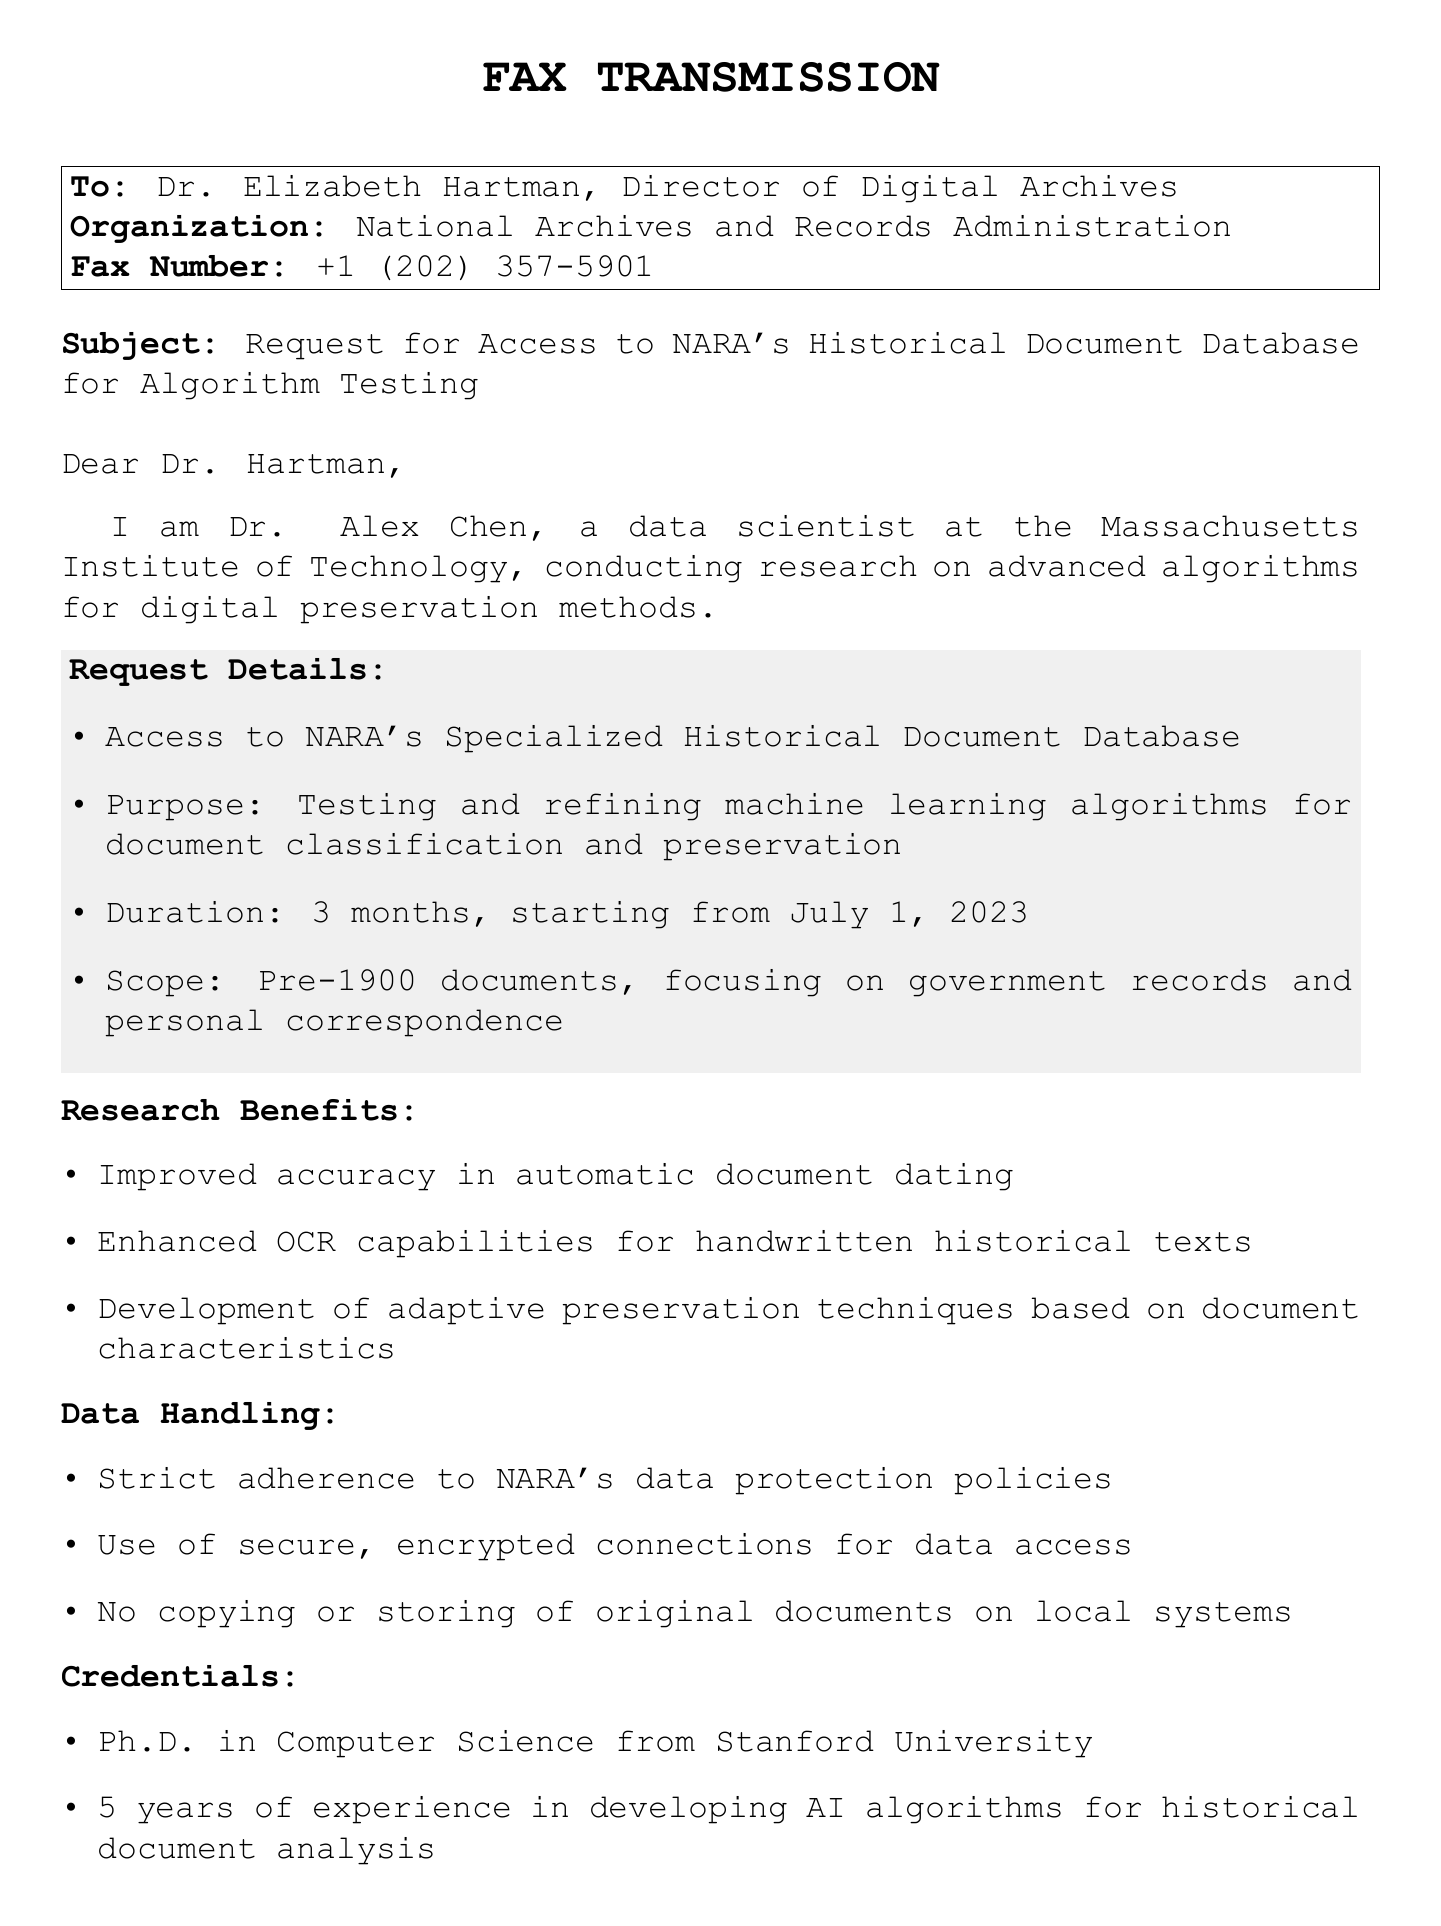what is the sender's name? The sender's name is mentioned in the document as Dr. Alex Chen.
Answer: Dr. Alex Chen who is the recipient of the fax? The document states that the fax is addressed to Dr. Elizabeth Hartman.
Answer: Dr. Elizabeth Hartman what organization is Dr. Hartman associated with? The document specifies that Dr. Hartman is the Director of Digital Archives at the National Archives and Records Administration.
Answer: National Archives and Records Administration what is the duration of the requested access? The document indicates that the duration of access requested is 3 months.
Answer: 3 months what is the primary purpose of the request? The main purpose stated in the document is for testing and refining machine learning algorithms for document classification and preservation.
Answer: Testing and refining machine learning algorithms how long is the testing period expected to start? The document specifies that the testing period is expected to start from July 1, 2023.
Answer: July 1, 2023 which category of documents is the focus of the request? The document mentions a specific focus on pre-1900 documents.
Answer: Pre-1900 documents what is mentioned as a benefit of this research? The document lists improved accuracy in automatic document dating as one of the benefits.
Answer: Improved accuracy in automatic document dating what is the email address of the sender? The sender's email address is provided in the document as a_chen@mit.edu.
Answer: a_chen@mit.edu how many years of experience does the sender have? The document states that the sender has 5 years of experience in developing AI algorithms for historical document analysis.
Answer: 5 years 